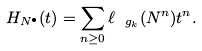Convert formula to latex. <formula><loc_0><loc_0><loc_500><loc_500>H _ { N ^ { \bullet } } ( t ) = \sum _ { n \geq 0 } \ell _ { \ g _ { k } } ( N ^ { n } ) t ^ { n } .</formula> 